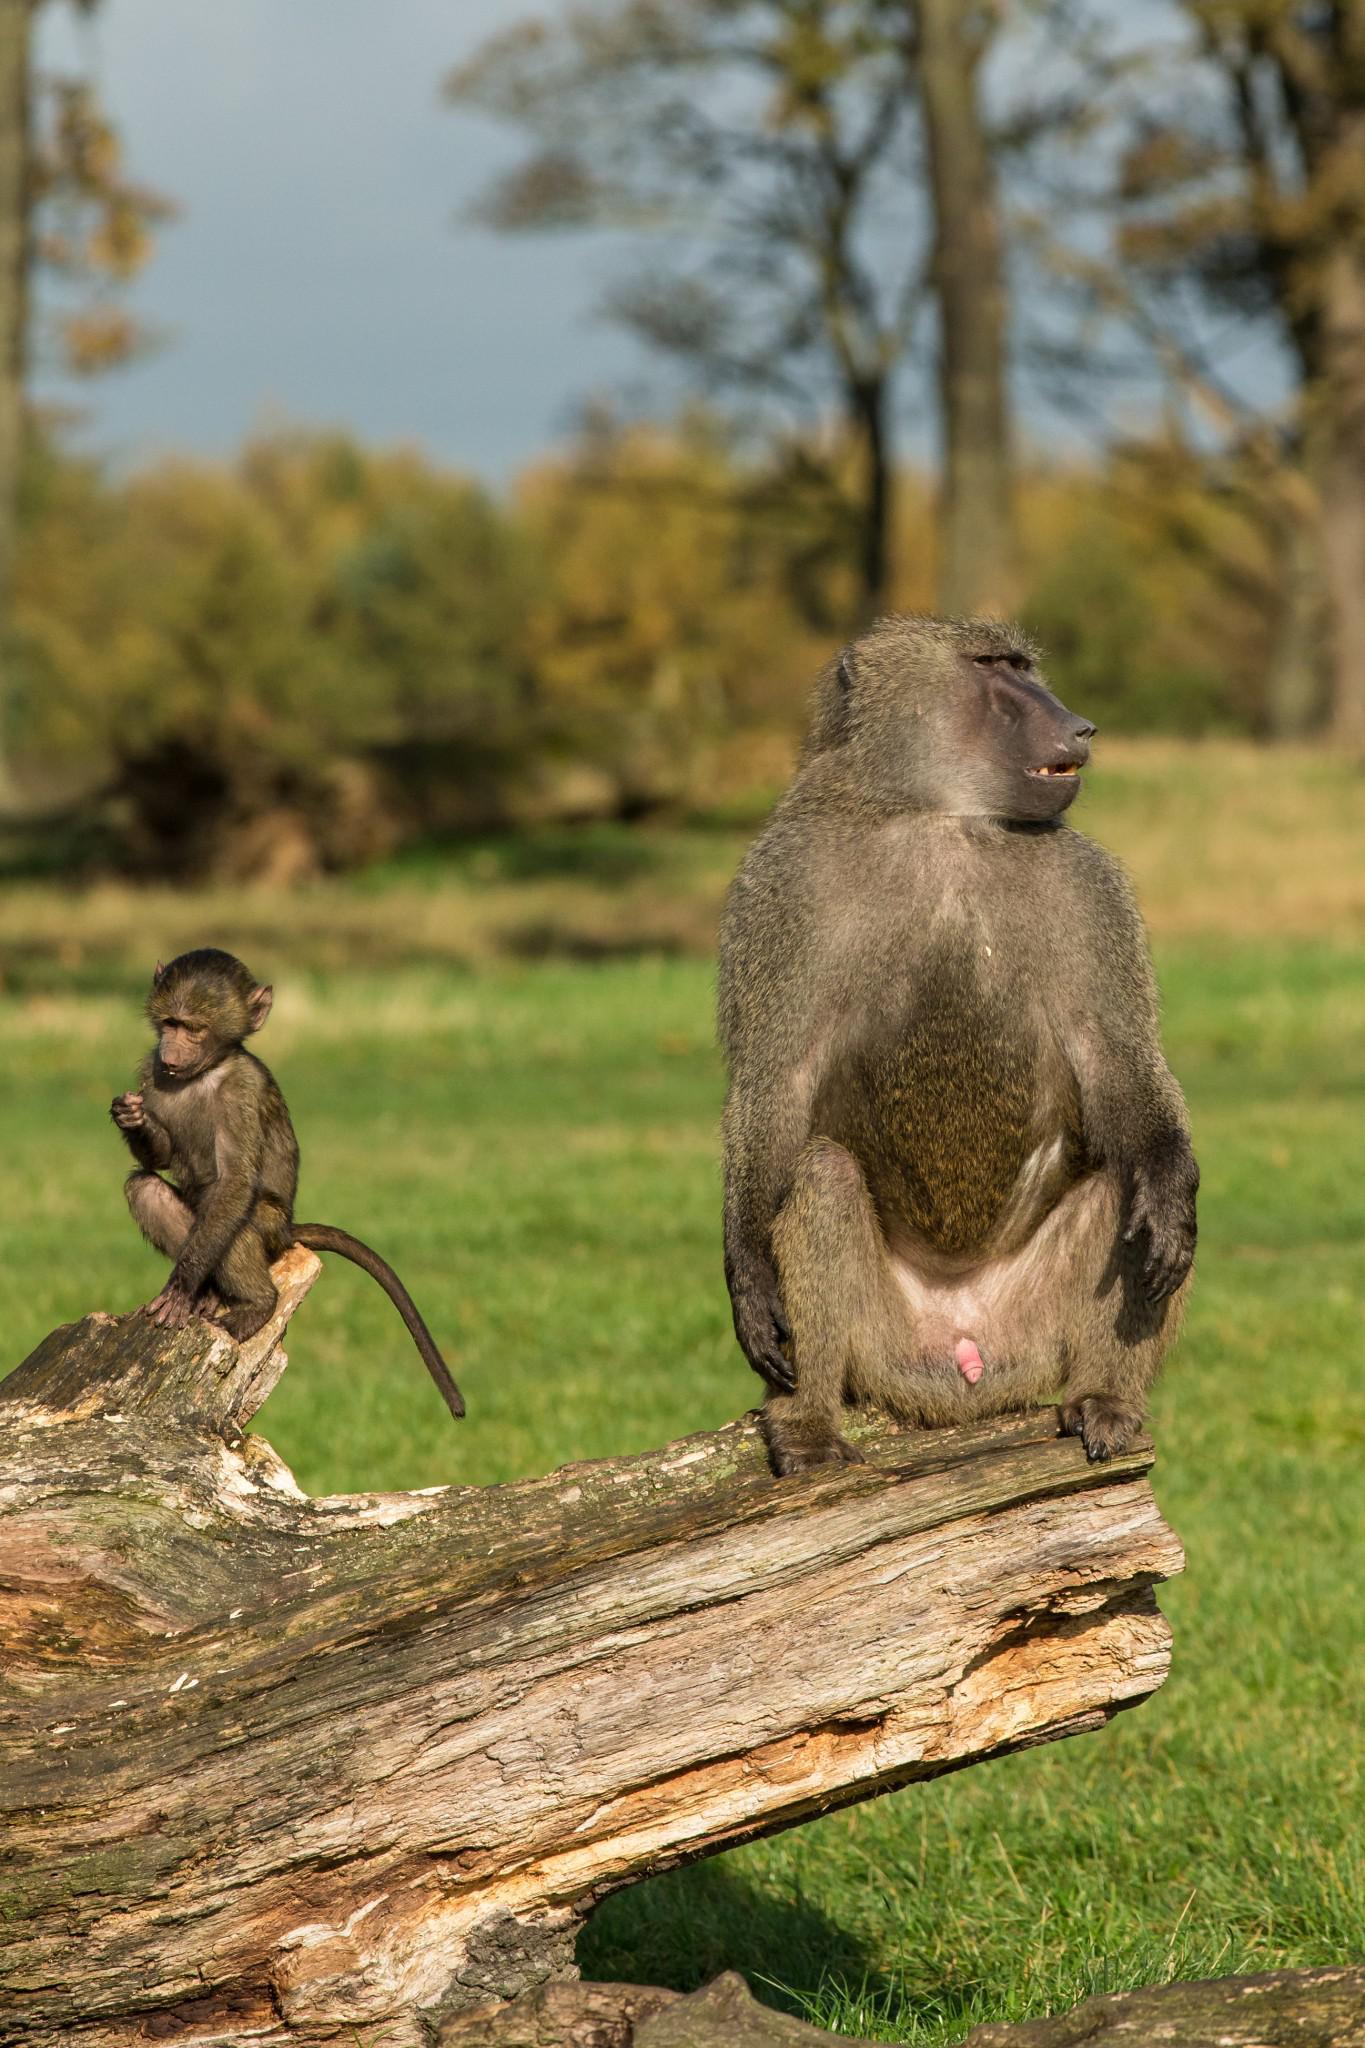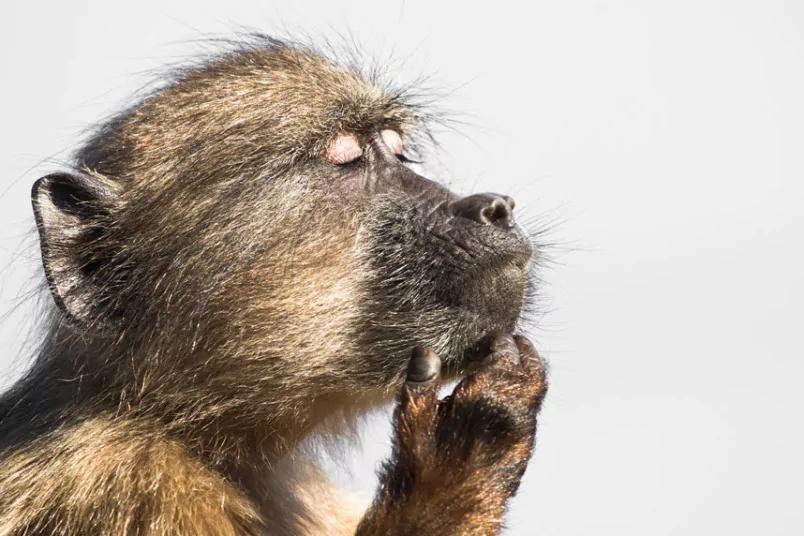The first image is the image on the left, the second image is the image on the right. Assess this claim about the two images: "There are more monkeys in the image on the right.". Correct or not? Answer yes or no. No. The first image is the image on the left, the second image is the image on the right. Considering the images on both sides, is "The left image shows exactly one adult baboon and one baby baboon." valid? Answer yes or no. Yes. 